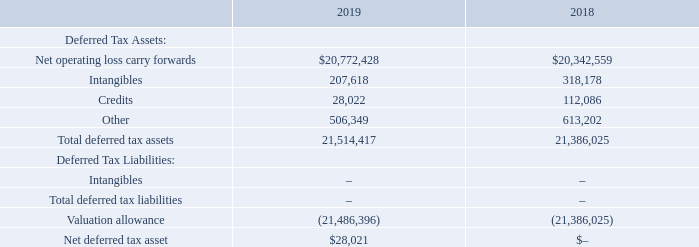NOTE L – INCOME TAXES
On December 22, 2017, the U.S. government enacted comprehensive tax legislation commonly referred to as the Tax Cuts and Jobs Act (the “Tax Act”). The Tax Act makes broad and complex changes to the U.S. tax code, including, but not limited to, the following that impact the Company: (1) reducing the U.S. federal corporate income tax rate from 35 percent to 21 percent; (2) eliminating the corporate alternative minimum tax; (3) creating a new limitation on deductible interest expense; (4) limiting the deductibility of certain executive compensation; and (5) limiting certain other deductions.
The Company follows ASC 740-10 “Income Taxes” which requires the recognition of deferred tax liabilities and assets for the expected future tax consequences of events that have been included in the financial statement or tax returns. Under this method, deferred tax liabilities and assets are determined based on the difference between financial statements and tax bases of assets and liabilities using enacted tax rates in effect for the year in which the differences are expected to reverse.
Deferred income taxes include the net tax effects of net operating loss (NOL) carry forwards and the temporary differences between the carrying amounts of assets and liabilities for financial reporting purposes and the amounts used for income tax purposes. Significant components of the Company's deferred tax assets are as follows:
When did the U.S. government enact the "Tax Act" ? December 22, 2017. How are deferred tax liabilities and assets determined under ASC 740-10? Determined based on the difference between financial statements and tax bases of assets and liabilities using enacted tax rates in effect for the year in which the differences are expected to reverse. What do the income taxes include? Net tax effects of net operating loss (nol) carry forwards and the temporary differences between the carrying amounts of assets and liabilities for financial reporting purposes and the amounts used for income tax purposes. What is the percentage change in the net operating loss carry forwards from 2018 to 2019?
Answer scale should be: percent. (20,772,428-20,342,559)/20,342,559
Answer: 2.11. What is the percentage change in the total deferred tax assets from 2018 to 2019?
Answer scale should be: percent. (21,514,417-21,386,025)/21,386,025
Answer: 0.6. Which year has the higher amount of intangibles (deferred tax assets)? Compare the value of the intangibles (deferred tax assets) between the two years
answer: 2018. 